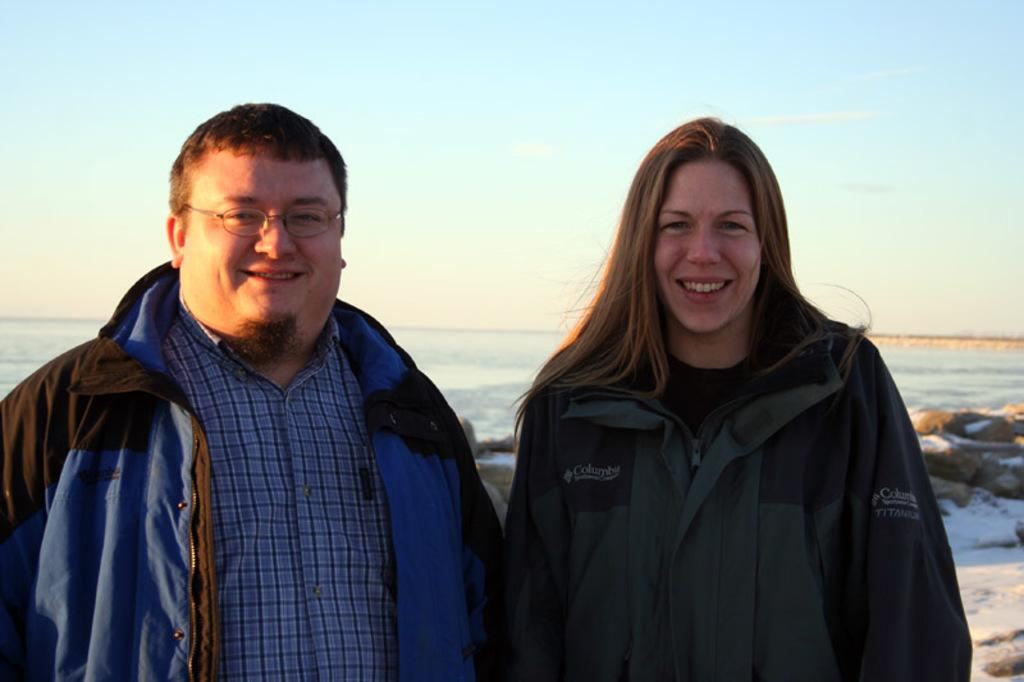Who can be seen in the foreground of the picture? There is a man and a woman in the foreground of the picture. What are the man and woman doing in the picture? The man and woman are smiling. What can be seen in the background of the picture? There is a water body and rocks in the background of the picture. How would you describe the weather in the picture? The sky is sunny in the picture. How many pigs are present in the picture? There are no pigs present in the picture. What type of addition problem can be solved using the rocks in the image? There is no addition problem involving the rocks in the image, as they are part of the background scenery. 